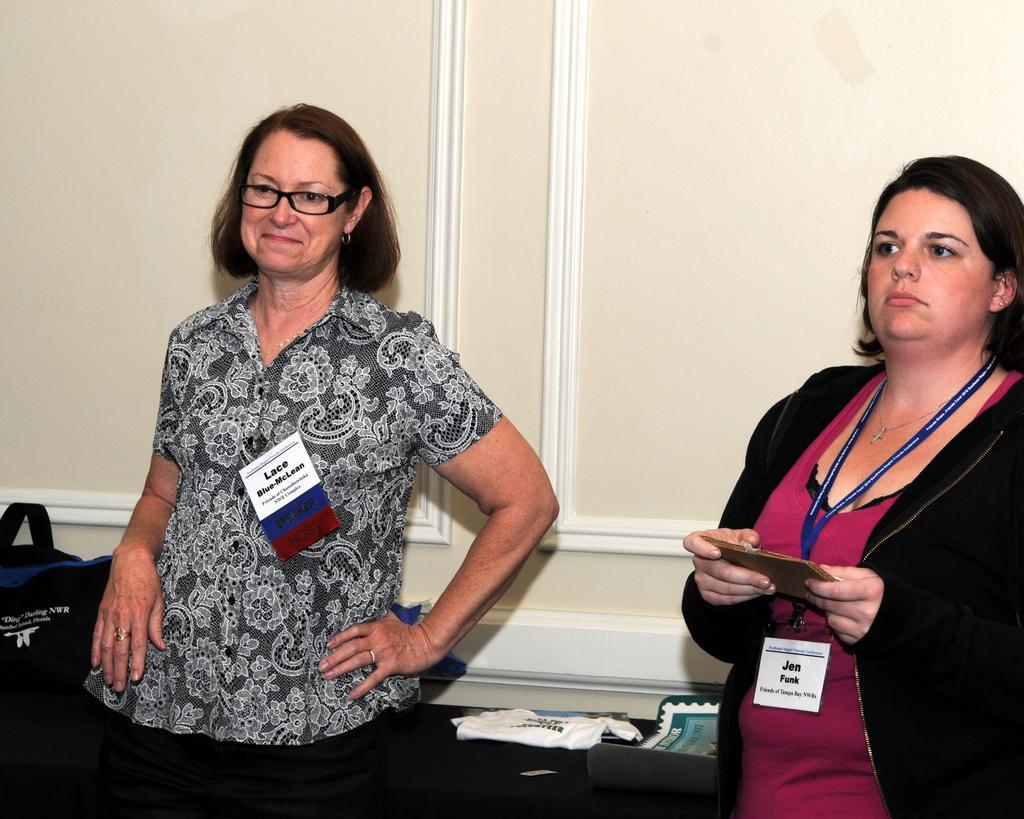Can you describe this image briefly? The picture consists of two women. On the right the woman is holding an object. In the background it is well. On the left there is a bag. In the center of the picture we can see a cloth and a file. 